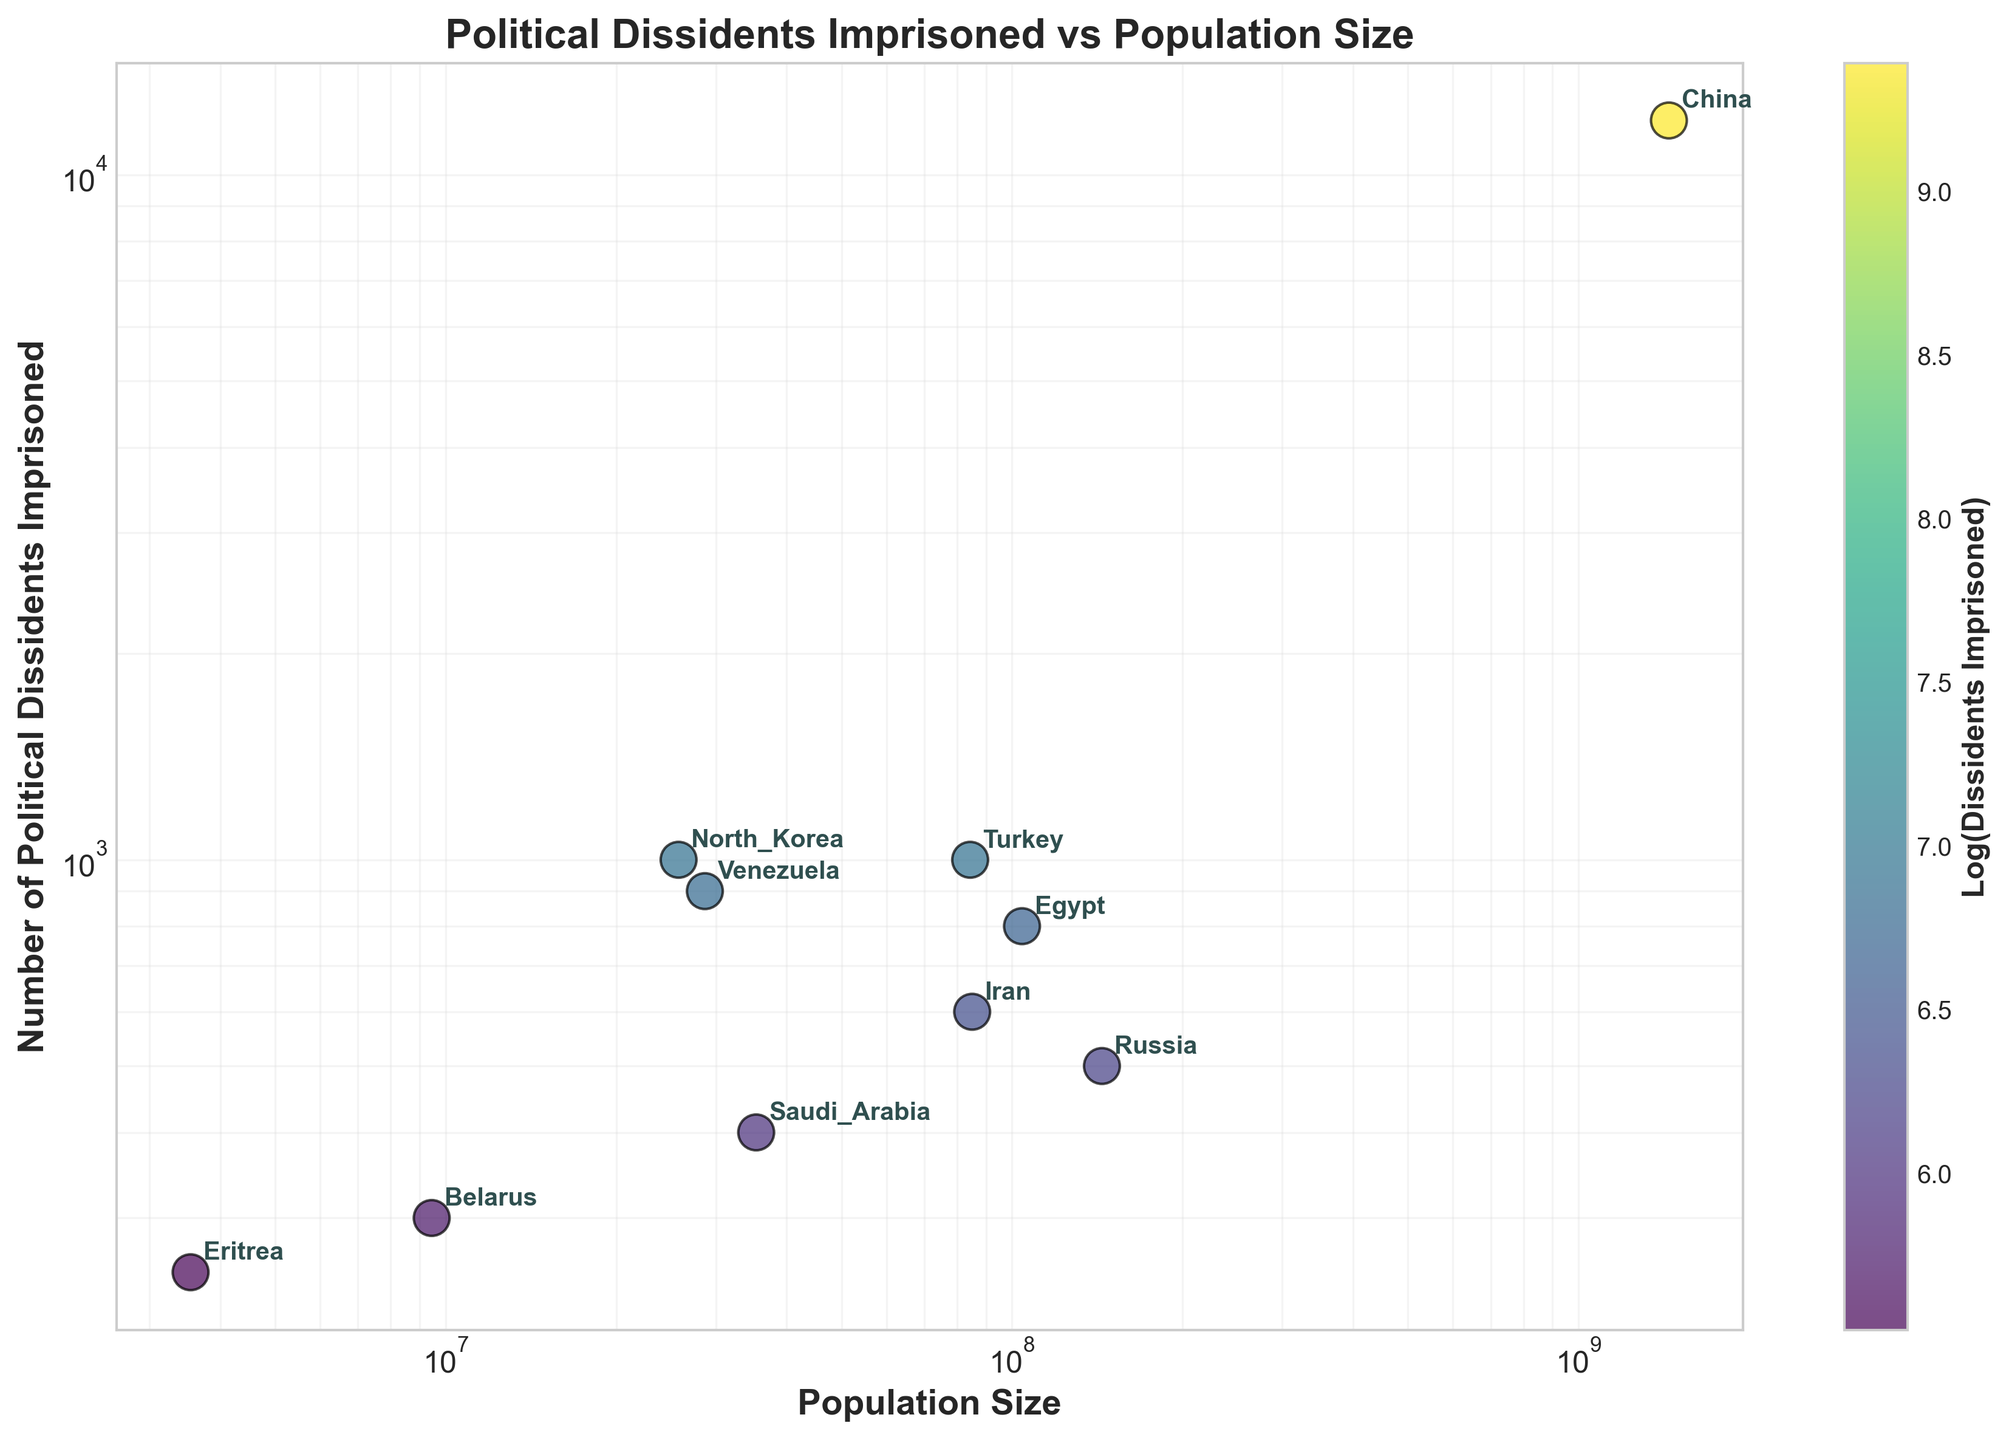What is the title of the figure? The title of the figure is typically located at the top center of the plot and provides a brief summary of the data being displayed.
Answer: Political Dissidents Imprisoned vs Population Size How many countries are represented in the plot? To find the number of countries represented, count the data points on the scatter plot. Each point corresponds to a country.
Answer: 10 Which country has the highest number of political dissidents imprisoned? The country with the highest number of political dissidents imprisoned will be the data point highest along the y-axis.
Answer: China What is the range of population sizes shown in the plot? The range of population sizes can be determined by identifying the smallest and largest values on the x-axis.
Answer: 3,546,000 to 1,444,216,107 How does the number of political dissidents imprisoned in Russia compare to that in Turkey? To compare the number of political dissidents imprisoned in Russia and Turkey, find their respective points on the scatter plot and see which one is higher along the y-axis.
Answer: Turkey has more Which country has the smallest number of political dissidents imprisoned? The country with the smallest number of political dissidents imprisoned will be at the lowest point along the y-axis.
Answer: Eritrea What is the average number of political dissidents imprisoned in countries with a population size greater than 100 million? Identify the countries with a population greater than 100 million, sum their number of political dissidents imprisoned, and divide by the number of such countries. The countries are China (12000), Russia (500), Egypt (800), which totals 12000 + 500 + 800 = 13300. Then, divide 13300 by the number of countries, 3.
Answer: 4433.33 Which country has a higher number of political dissidents imprisoned relative to its population size: North Korea or Belarus? Calculate the ratio of political dissidents imprisoned to population size for both countries by dividing the number of political dissidents by the population size. Compare these ratios. North Korea: 1000/25778816 ≈ 0.0000388. Belarus: 300/9449323 ≈ 0.0000317
Answer: North Korea Why does the color of the dots change, and what does it represent? The color of the dots changes based on the log-scaled number of political dissidents imprisoned, with the color bar on the side indicating this relationship. Darker colors represent a higher log value.
Answer: Color represents log(Dissidents Imprisoned) Is there a general trend between population size and the number of political dissidents imprisoned? Examine the scatter plot to determine if there is a pattern or trend between population size (x-axis) and the number of political dissidents imprisoned (y-axis).
Answer: No clear trend 